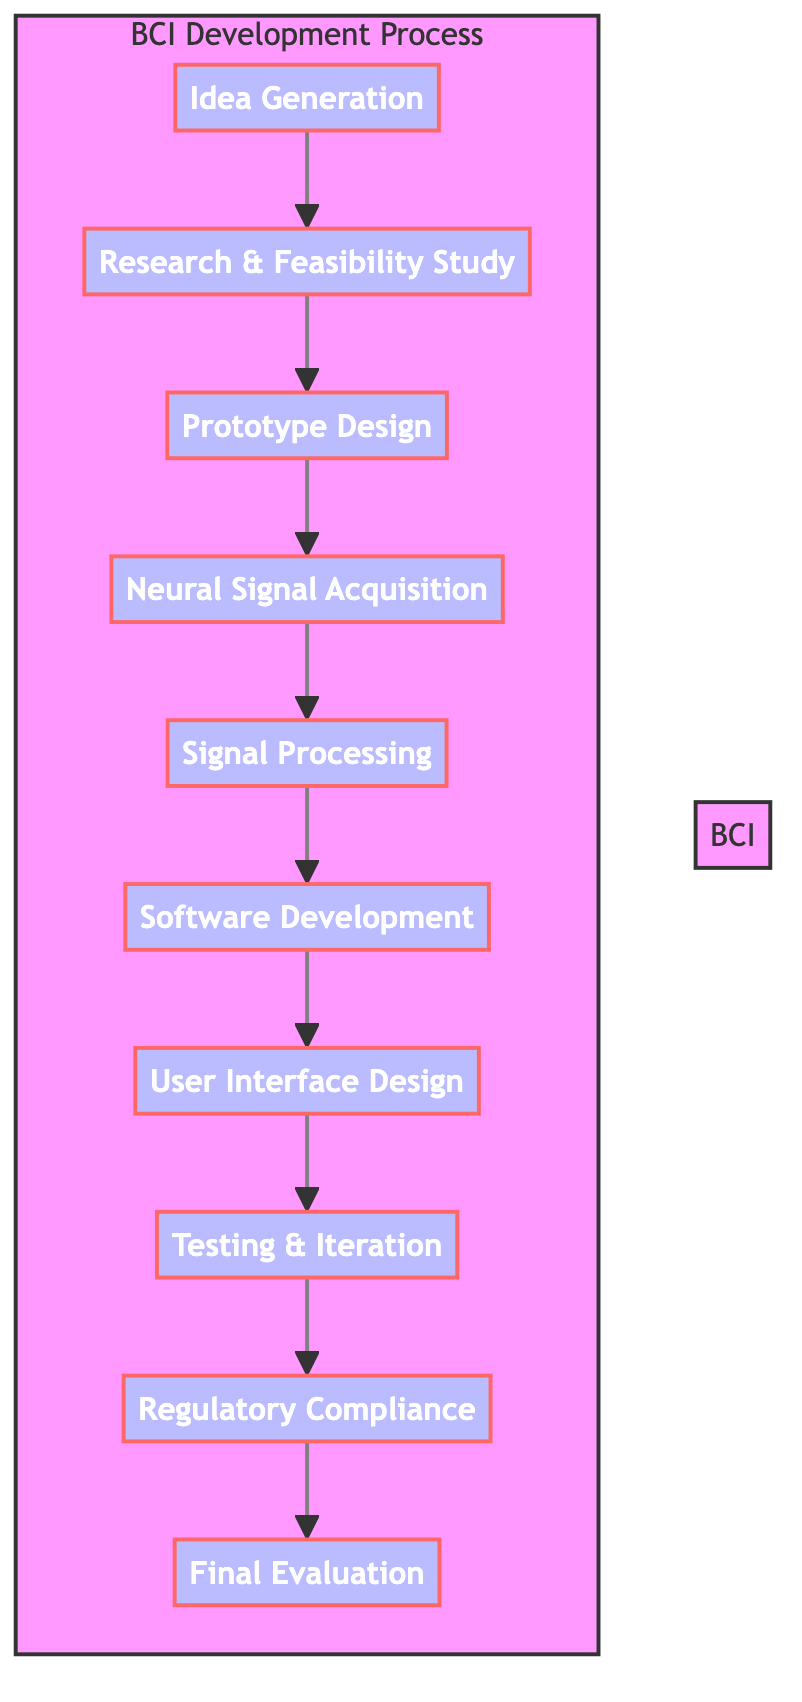What's the first step in the BCI development process? The diagram indicates that the first step is "Idea Generation," which initiates the entire process.
Answer: Idea Generation How many total steps are there in the BCI development process? By counting the elements in the diagram, there are ten distinct steps from conception to final evaluation.
Answer: Ten What step directly follows "Neural Signal Acquisition"? The diagram shows that "Signal Processing" follows directly after "Neural Signal Acquisition," which is the next stage in the sequence.
Answer: Signal Processing What is the last step of the BCI development process? The diagram indicates that the last step is "Final Evaluation," which concludes the process and assesses overall performance and usability.
Answer: Final Evaluation Which step involves creating initial designs? According to the flowchart, "Prototype Design" is the step where initial designs and materials for the BCI hardware are created.
Answer: Prototype Design What do "Software Development" and "User Interface Design" have in common? Both steps are related to the software aspect of the BCI, where software development involves building the interface, and user interface design focuses on creating a user-friendly interaction experience.
Answer: Software aspect Which step ensures compliance with health and safety regulations? The diagram shows that "Regulatory Compliance" is specifically the step that focuses on meeting necessary health and safety standards.
Answer: Regulatory Compliance What step comes before "Testing & Iteration"? The diagram illustrates that "User Interface Design" precedes "Testing & Iteration," contributing to the preparation for testing.
Answer: User Interface Design How is new feedback implemented during the process? "Testing & Iteration" is the step where user feedback is incorporated to refine the BCI, illustrating its key role in improving the interface based on real user experiences.
Answer: Testing & Iteration What is the purpose of "Signal Processing"? The diagram states that "Signal Processing" is for developing algorithms to interpret brain signals into actionable data, which is crucial for the BCI's functionality.
Answer: Develop algorithms 